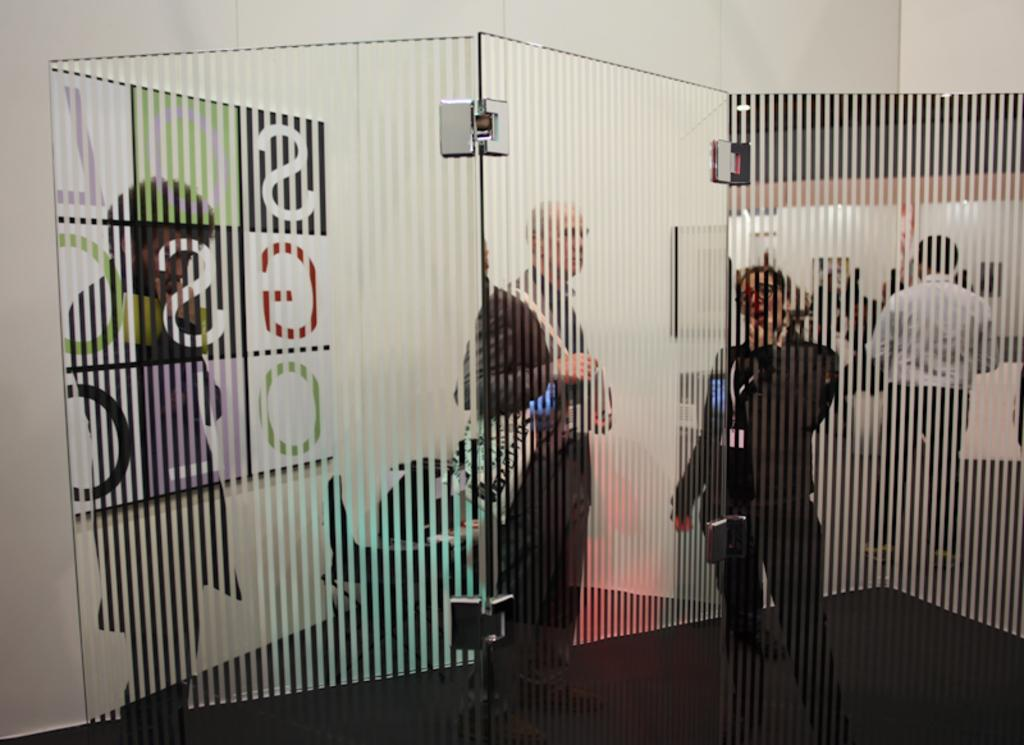What object is located in the front of the image? There is a glass in the front of the image. What can be seen in the background of the image? There are persons standing in the background of the image, and there is a white wall. What type of marble is visible on the floor in the image? There is no marble visible on the floor in the image; the background features a white wall and persons standing. 